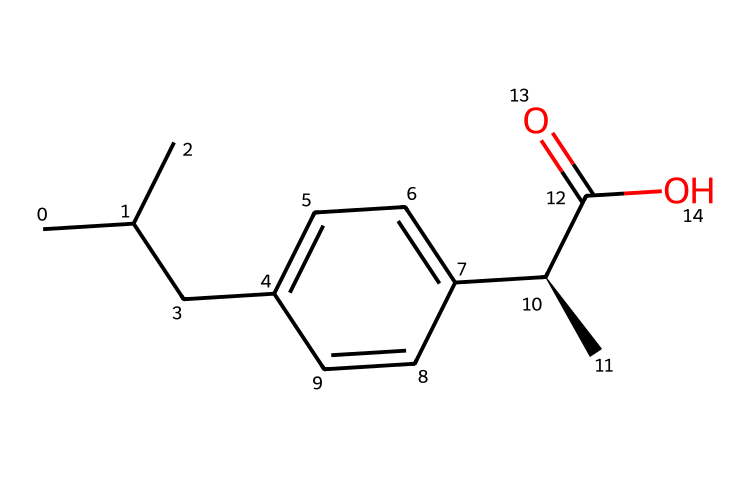How many carbon atoms are in ibuprofen? The SMILES representation indicates the number of carbon (C) atoms by counting each occurrence of the letter "C". In this compound, there are a total of 13 carbon atoms.
Answer: 13 What functional group is present in ibuprofen? By analyzing the SMILES, we can identify the -COOH group, known as a carboxylic acid functional group, present in the structure. This is indicated by the "C(=O)O" portion of the SMILES.
Answer: carboxylic acid What is the total number of double bonds in ibuprofen? In the SMILES representation, double bonds are denoted by an "=" sign. There is one double bond present in the compound, specifically in the carbonyl group (C=O).
Answer: 1 What is the stereochemistry at the chiral center of ibuprofen? The "C@H" notation in the SMILES indicates that there is a chiral center in this molecule. This shows that ibuprofen has a specific stereoconfiguration, generally recognized as the S-form (S-ibuprofen).
Answer: S How many rings are present in ibuprofen? Observing the SMILES indicates that there are no ring structures in this molecule, as there is no occurrence of numbers that would indicate a ring closure.
Answer: 0 What type of medicinal compound is ibuprofen? Ibuprofen is classified as a non-steroidal anti-inflammatory drug (NSAID), recognized for its ability to reduce inflammation and pain, as evident from its structure and function.
Answer: NSAID 